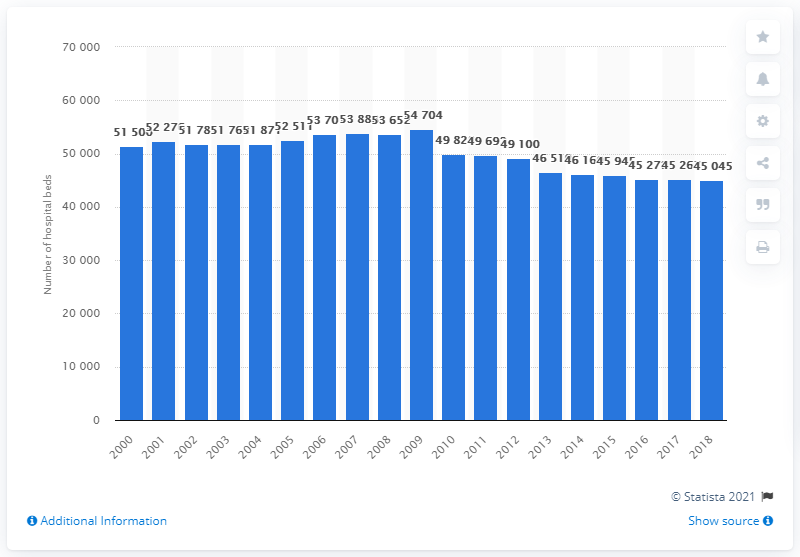Point out several critical features in this image. In 2018, there were 45,045 hospital beds in Greece. 